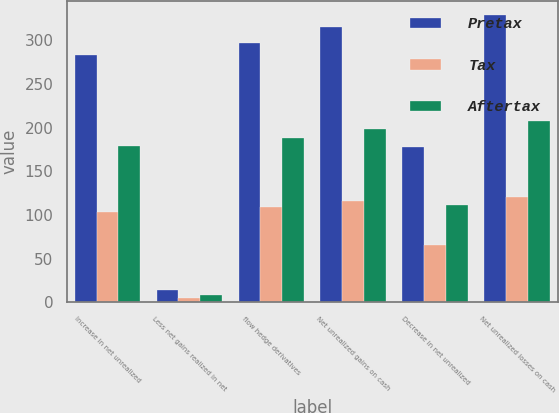Convert chart to OTSL. <chart><loc_0><loc_0><loc_500><loc_500><stacked_bar_chart><ecel><fcel>Increase in net unrealized<fcel>Less net gains realized in net<fcel>flow hedge derivatives<fcel>Net unrealized gains on cash<fcel>Decrease in net unrealized<fcel>Net unrealized losses on cash<nl><fcel>Pretax<fcel>283<fcel>14<fcel>297<fcel>315<fcel>178<fcel>329<nl><fcel>Tax<fcel>104<fcel>5<fcel>109<fcel>116<fcel>66<fcel>121<nl><fcel>Aftertax<fcel>179<fcel>9<fcel>188<fcel>199<fcel>112<fcel>208<nl></chart> 